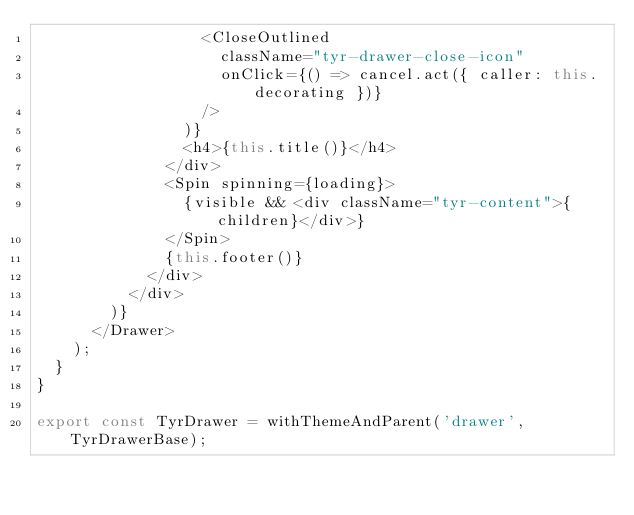<code> <loc_0><loc_0><loc_500><loc_500><_TypeScript_>                  <CloseOutlined
                    className="tyr-drawer-close-icon"
                    onClick={() => cancel.act({ caller: this.decorating })}
                  />
                )}
                <h4>{this.title()}</h4>
              </div>
              <Spin spinning={loading}>
                {visible && <div className="tyr-content">{children}</div>}
              </Spin>
              {this.footer()}
            </div>
          </div>
        )}
      </Drawer>
    );
  }
}

export const TyrDrawer = withThemeAndParent('drawer', TyrDrawerBase);
</code> 